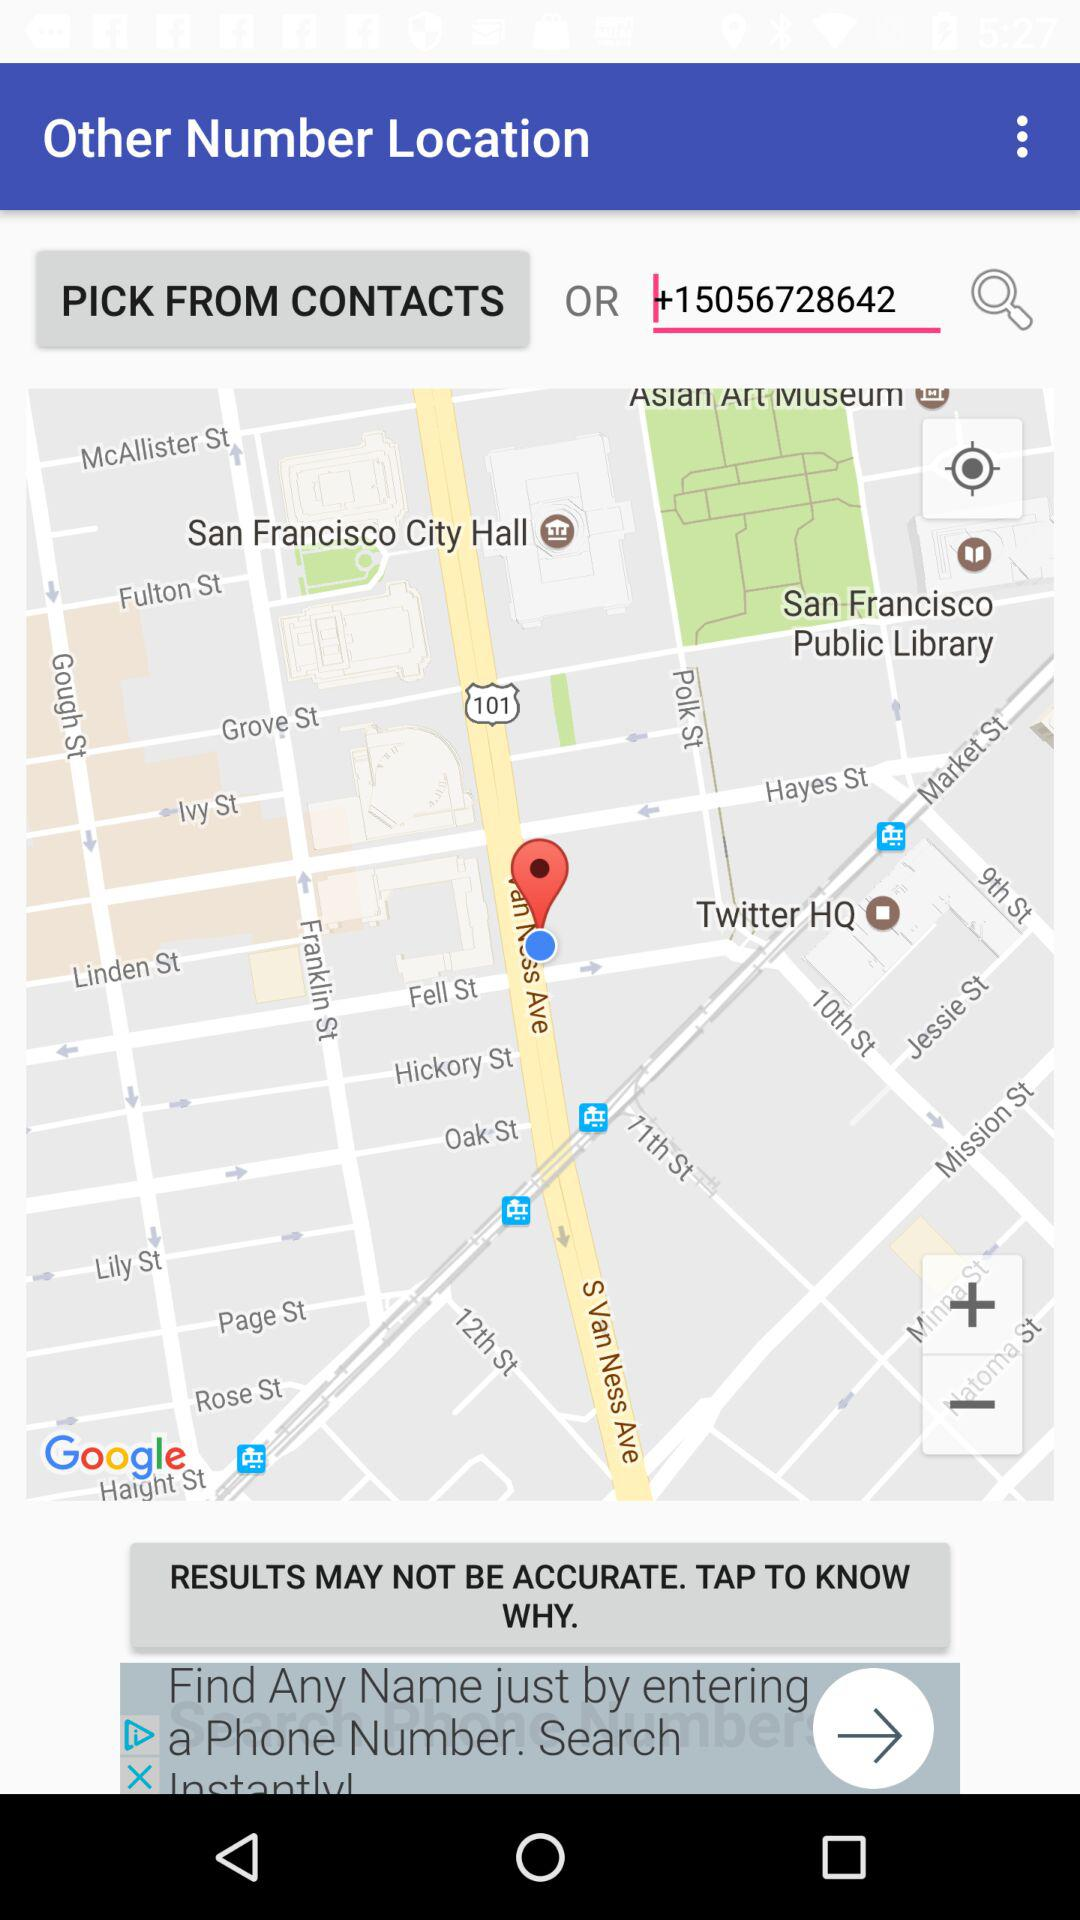What is the number in the search field? The number in the search field is +15056728642. 